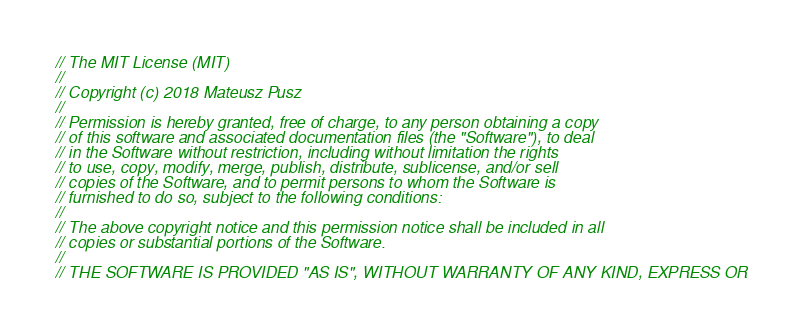<code> <loc_0><loc_0><loc_500><loc_500><_C_>// The MIT License (MIT)
//
// Copyright (c) 2018 Mateusz Pusz
//
// Permission is hereby granted, free of charge, to any person obtaining a copy
// of this software and associated documentation files (the "Software"), to deal
// in the Software without restriction, including without limitation the rights
// to use, copy, modify, merge, publish, distribute, sublicense, and/or sell
// copies of the Software, and to permit persons to whom the Software is
// furnished to do so, subject to the following conditions:
//
// The above copyright notice and this permission notice shall be included in all
// copies or substantial portions of the Software.
//
// THE SOFTWARE IS PROVIDED "AS IS", WITHOUT WARRANTY OF ANY KIND, EXPRESS OR</code> 